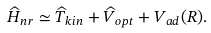Convert formula to latex. <formula><loc_0><loc_0><loc_500><loc_500>\widehat { H } _ { n r } \simeq \widehat { T } _ { k i n } + \widehat { V } _ { o p t } + V _ { a d } ( R ) .</formula> 